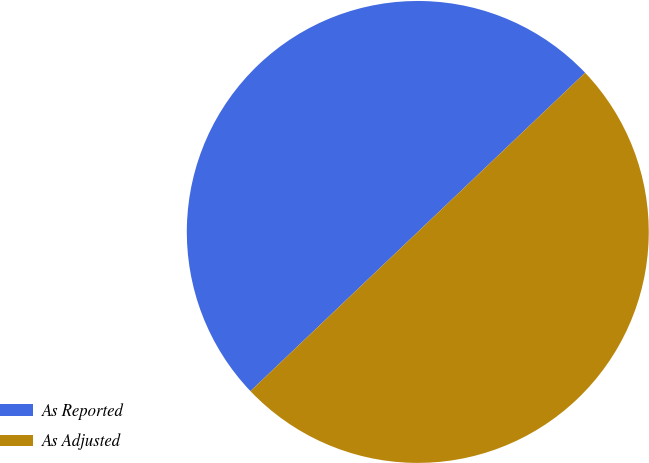<chart> <loc_0><loc_0><loc_500><loc_500><pie_chart><fcel>As Reported<fcel>As Adjusted<nl><fcel>50.0%<fcel>50.0%<nl></chart> 